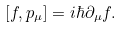<formula> <loc_0><loc_0><loc_500><loc_500>[ f , p _ { \mu } ] = i \hbar { \partial } _ { \mu } f .</formula> 